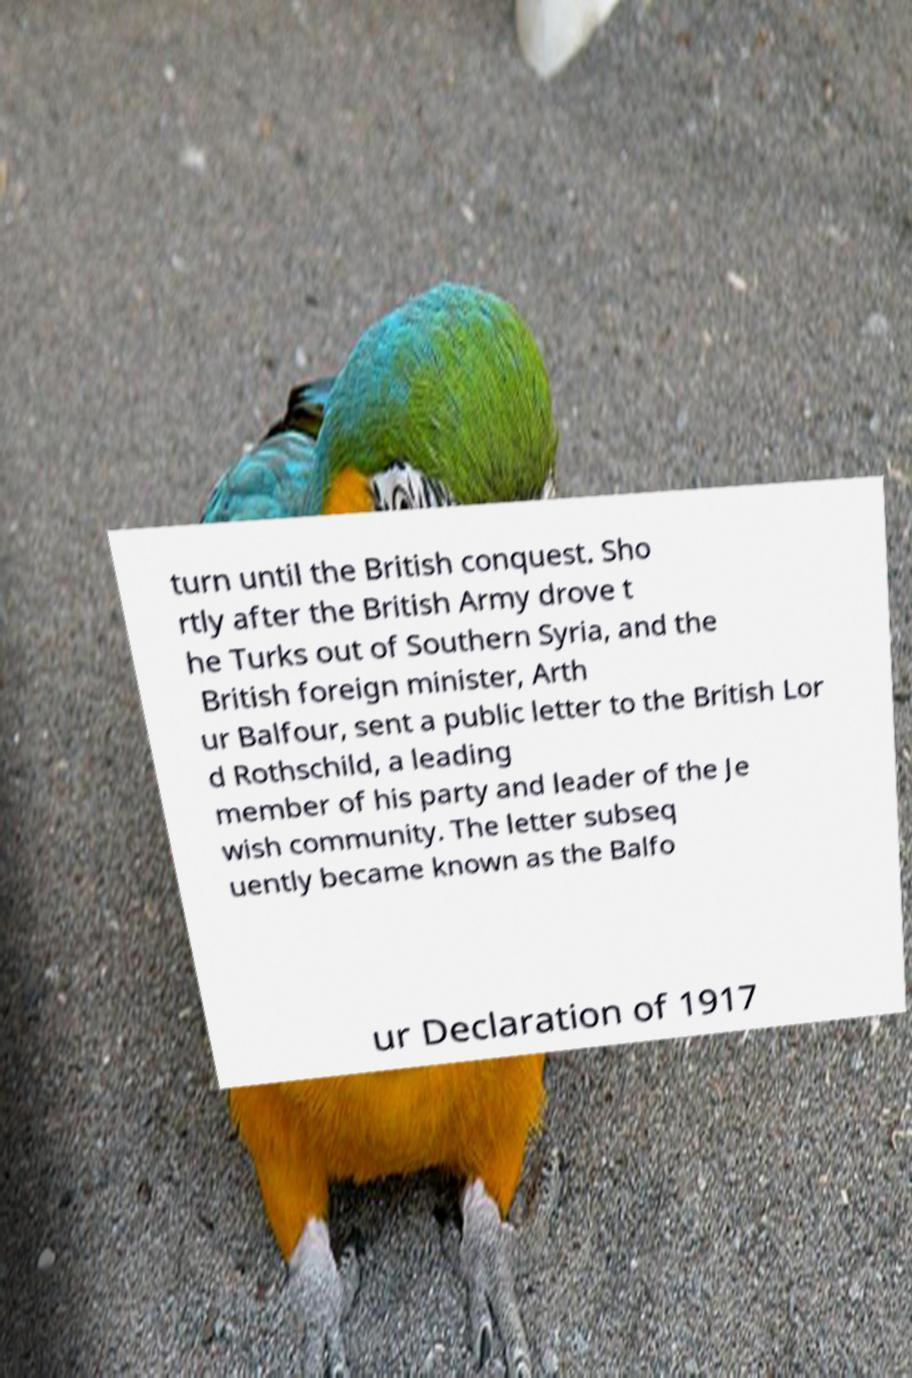What messages or text are displayed in this image? I need them in a readable, typed format. turn until the British conquest. Sho rtly after the British Army drove t he Turks out of Southern Syria, and the British foreign minister, Arth ur Balfour, sent a public letter to the British Lor d Rothschild, a leading member of his party and leader of the Je wish community. The letter subseq uently became known as the Balfo ur Declaration of 1917 